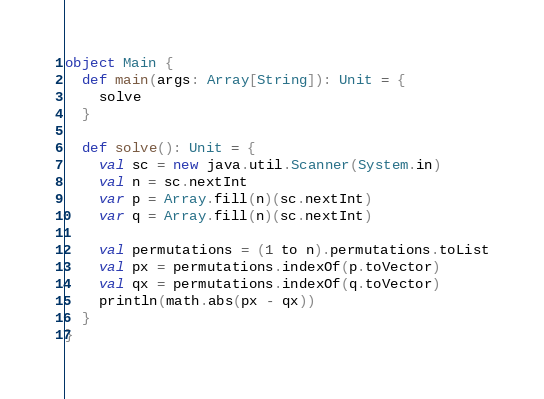Convert code to text. <code><loc_0><loc_0><loc_500><loc_500><_Scala_>object Main {
  def main(args: Array[String]): Unit = {
    solve
  }

  def solve(): Unit = {
    val sc = new java.util.Scanner(System.in)
    val n = sc.nextInt
    var p = Array.fill(n)(sc.nextInt)
    var q = Array.fill(n)(sc.nextInt)

    val permutations = (1 to n).permutations.toList
    val px = permutations.indexOf(p.toVector)
    val qx = permutations.indexOf(q.toVector)
    println(math.abs(px - qx))
  }
}
</code> 